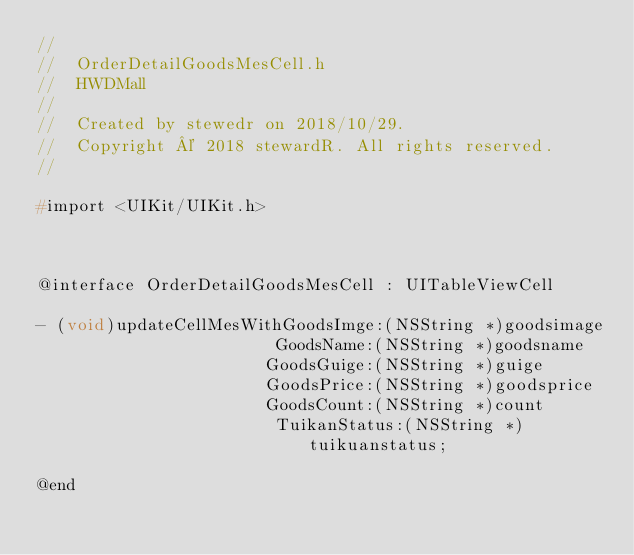Convert code to text. <code><loc_0><loc_0><loc_500><loc_500><_C_>//
//  OrderDetailGoodsMesCell.h
//  HWDMall
//
//  Created by stewedr on 2018/10/29.
//  Copyright © 2018 stewardR. All rights reserved.
//

#import <UIKit/UIKit.h>



@interface OrderDetailGoodsMesCell : UITableViewCell

- (void)updateCellMesWithGoodsImge:(NSString *)goodsimage
                        GoodsName:(NSString *)goodsname
                       GoodsGuige:(NSString *)guige
                       GoodsPrice:(NSString *)goodsprice
                       GoodsCount:(NSString *)count
                        TuikanStatus:(NSString *)tuikuanstatus;

@end


</code> 